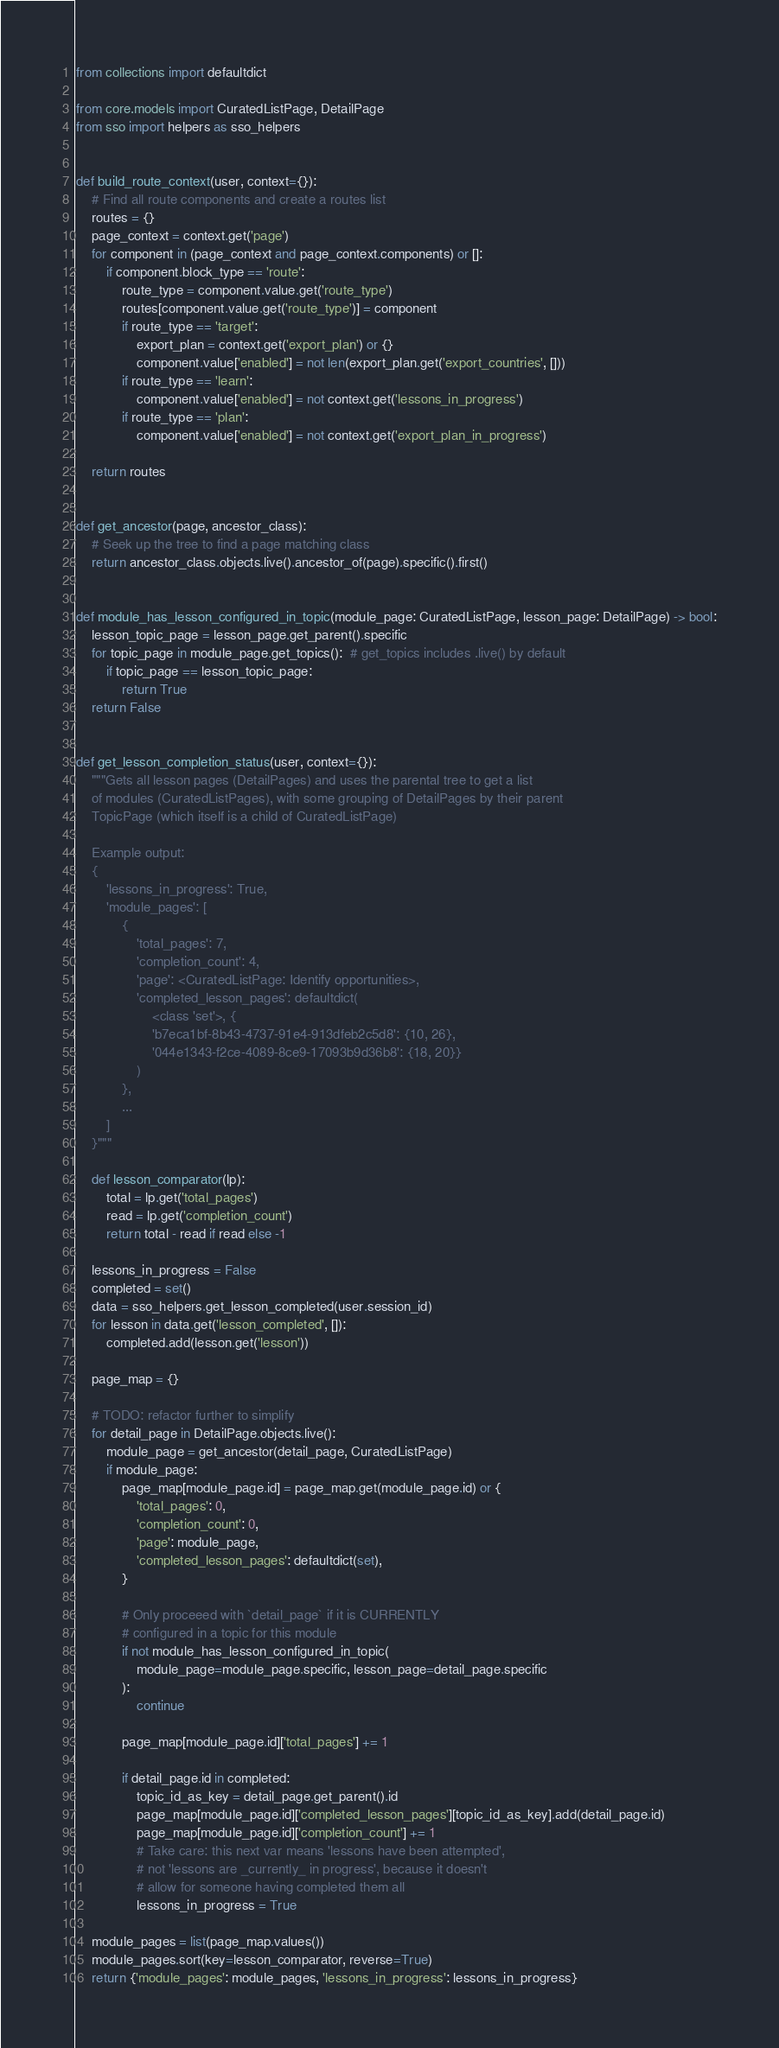Convert code to text. <code><loc_0><loc_0><loc_500><loc_500><_Python_>from collections import defaultdict

from core.models import CuratedListPage, DetailPage
from sso import helpers as sso_helpers


def build_route_context(user, context={}):
    # Find all route components and create a routes list
    routes = {}
    page_context = context.get('page')
    for component in (page_context and page_context.components) or []:
        if component.block_type == 'route':
            route_type = component.value.get('route_type')
            routes[component.value.get('route_type')] = component
            if route_type == 'target':
                export_plan = context.get('export_plan') or {}
                component.value['enabled'] = not len(export_plan.get('export_countries', []))
            if route_type == 'learn':
                component.value['enabled'] = not context.get('lessons_in_progress')
            if route_type == 'plan':
                component.value['enabled'] = not context.get('export_plan_in_progress')

    return routes


def get_ancestor(page, ancestor_class):
    # Seek up the tree to find a page matching class
    return ancestor_class.objects.live().ancestor_of(page).specific().first()


def module_has_lesson_configured_in_topic(module_page: CuratedListPage, lesson_page: DetailPage) -> bool:
    lesson_topic_page = lesson_page.get_parent().specific
    for topic_page in module_page.get_topics():  # get_topics includes .live() by default
        if topic_page == lesson_topic_page:
            return True
    return False


def get_lesson_completion_status(user, context={}):
    """Gets all lesson pages (DetailPages) and uses the parental tree to get a list
    of modules (CuratedListPages), with some grouping of DetailPages by their parent
    TopicPage (which itself is a child of CuratedListPage)

    Example output:
    {
        'lessons_in_progress': True,
        'module_pages': [
            {
                'total_pages': 7,
                'completion_count': 4,
                'page': <CuratedListPage: Identify opportunities>,
                'completed_lesson_pages': defaultdict(
                    <class 'set'>, {
                    'b7eca1bf-8b43-4737-91e4-913dfeb2c5d8': {10, 26},
                    '044e1343-f2ce-4089-8ce9-17093b9d36b8': {18, 20}}
                )
            },
            ...
        ]
    }"""

    def lesson_comparator(lp):
        total = lp.get('total_pages')
        read = lp.get('completion_count')
        return total - read if read else -1

    lessons_in_progress = False
    completed = set()
    data = sso_helpers.get_lesson_completed(user.session_id)
    for lesson in data.get('lesson_completed', []):
        completed.add(lesson.get('lesson'))

    page_map = {}

    # TODO: refactor further to simplify
    for detail_page in DetailPage.objects.live():
        module_page = get_ancestor(detail_page, CuratedListPage)
        if module_page:
            page_map[module_page.id] = page_map.get(module_page.id) or {
                'total_pages': 0,
                'completion_count': 0,
                'page': module_page,
                'completed_lesson_pages': defaultdict(set),
            }

            # Only proceeed with `detail_page` if it is CURRENTLY
            # configured in a topic for this module
            if not module_has_lesson_configured_in_topic(
                module_page=module_page.specific, lesson_page=detail_page.specific
            ):
                continue

            page_map[module_page.id]['total_pages'] += 1

            if detail_page.id in completed:
                topic_id_as_key = detail_page.get_parent().id
                page_map[module_page.id]['completed_lesson_pages'][topic_id_as_key].add(detail_page.id)
                page_map[module_page.id]['completion_count'] += 1
                # Take care: this next var means 'lessons have been attempted',
                # not 'lessons are _currently_ in progress', because it doesn't
                # allow for someone having completed them all
                lessons_in_progress = True

    module_pages = list(page_map.values())
    module_pages.sort(key=lesson_comparator, reverse=True)
    return {'module_pages': module_pages, 'lessons_in_progress': lessons_in_progress}
</code> 